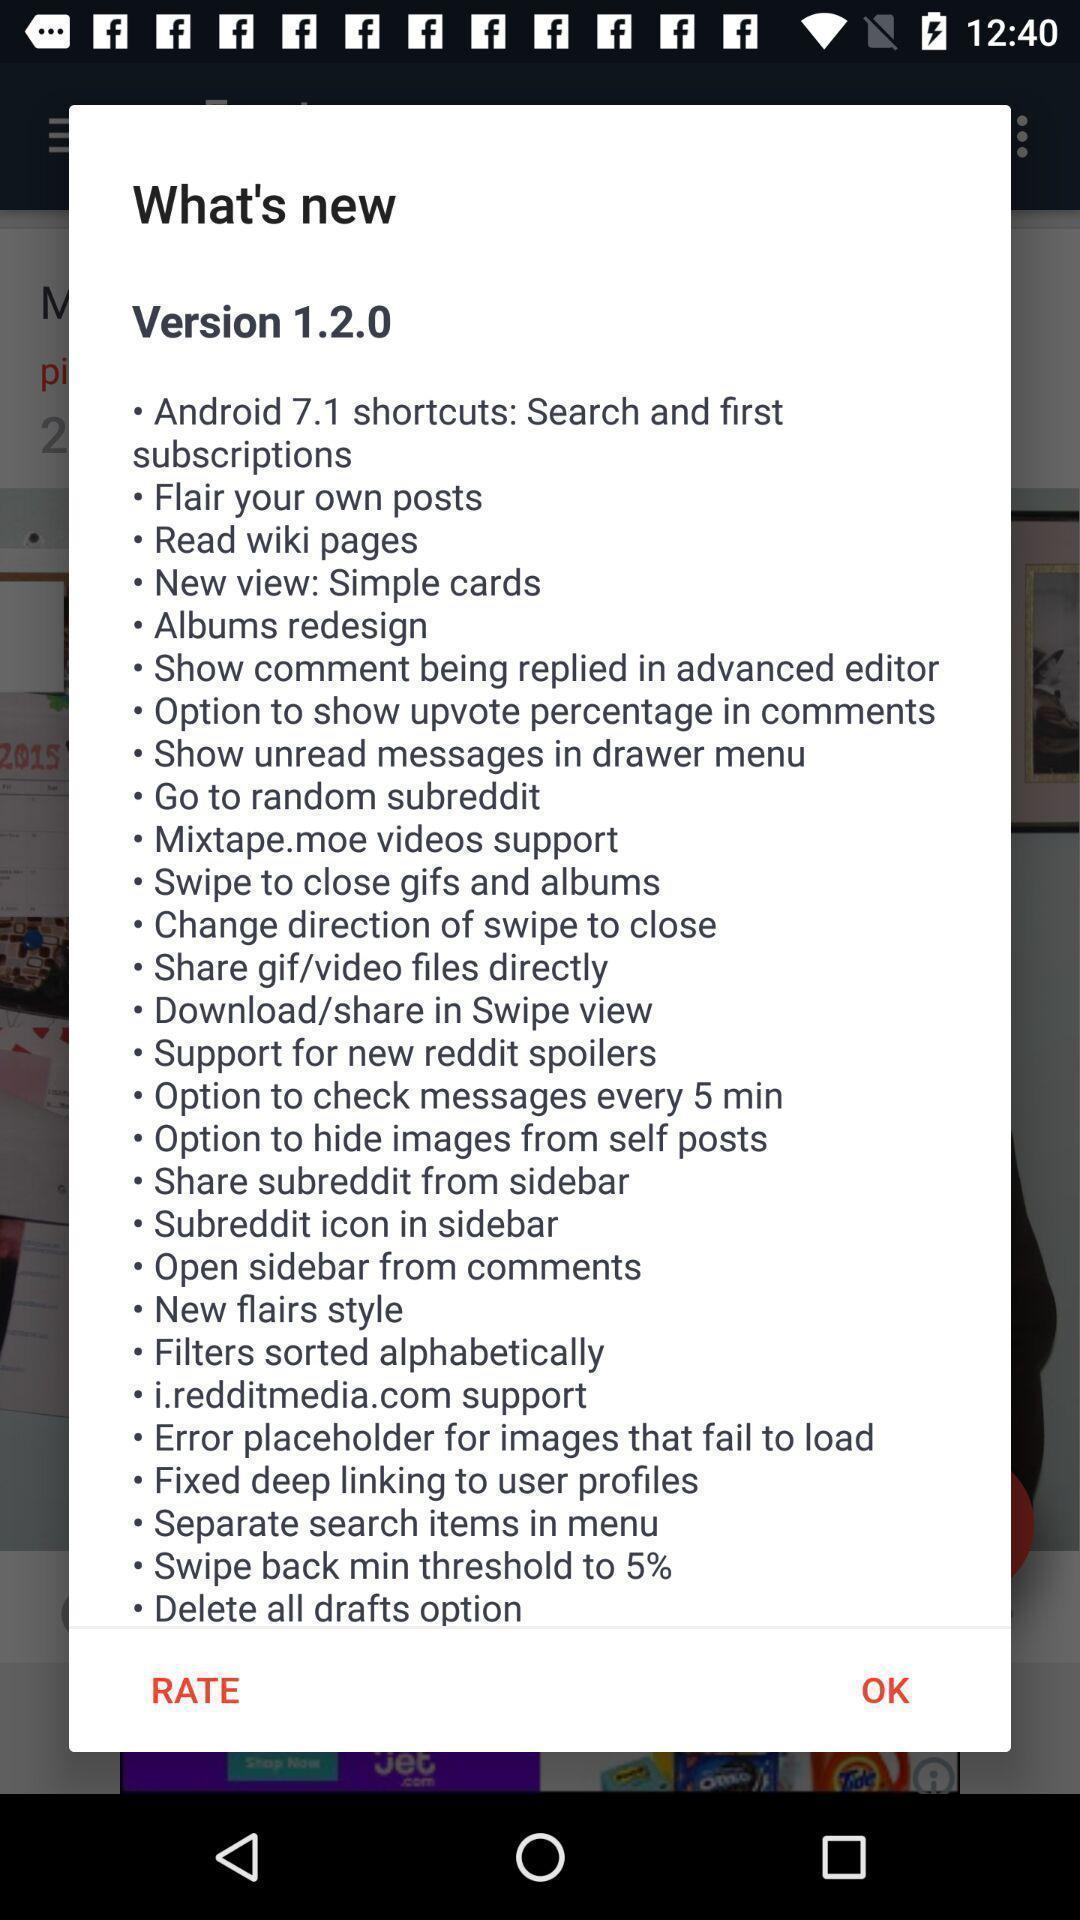Tell me what you see in this picture. Pop-up displays update version. 